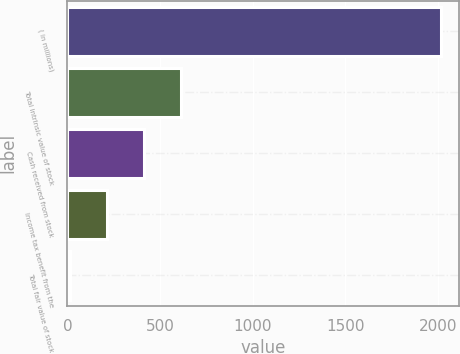Convert chart. <chart><loc_0><loc_0><loc_500><loc_500><bar_chart><fcel>( in millions)<fcel>Total intrinsic value of stock<fcel>Cash received from stock<fcel>Income tax benefit from the<fcel>Total fair value of stock<nl><fcel>2015<fcel>613.6<fcel>413.4<fcel>213.2<fcel>13<nl></chart> 